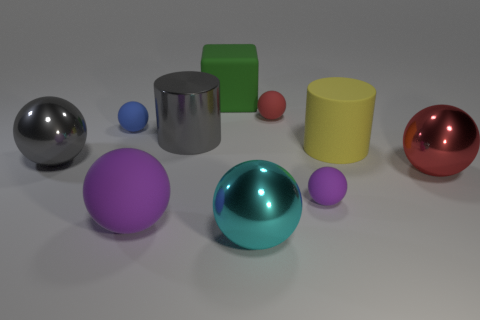Subtract all gray spheres. How many spheres are left? 6 Subtract 4 spheres. How many spheres are left? 3 Subtract all purple spheres. How many spheres are left? 5 Subtract all gray spheres. Subtract all cyan blocks. How many spheres are left? 6 Subtract all spheres. How many objects are left? 3 Add 2 yellow cylinders. How many yellow cylinders exist? 3 Subtract 0 purple blocks. How many objects are left? 10 Subtract all small yellow objects. Subtract all big balls. How many objects are left? 6 Add 5 red things. How many red things are left? 7 